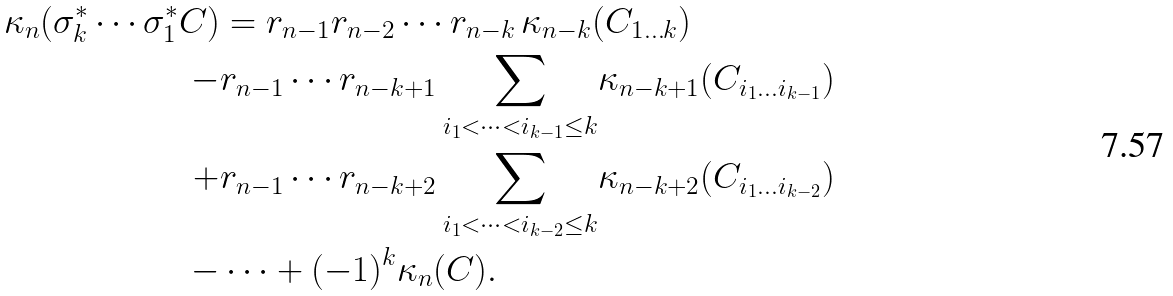<formula> <loc_0><loc_0><loc_500><loc_500>\kappa _ { n } ( \sigma _ { k } ^ { * } \cdots \sigma _ { 1 } ^ { * } C ) & = r _ { n - 1 } r _ { n - 2 } \cdots r _ { n - k } \, \kappa _ { n - k } ( C _ { 1 \dots k } ) \\ - & r _ { n - 1 } \cdots r _ { n - k + 1 } \, \underset { i _ { 1 } < \cdots < i _ { k - 1 } \leq k } { \sum } \kappa _ { n - k + 1 } ( C _ { i _ { 1 } \dots i _ { k - 1 } } ) \\ + & r _ { n - 1 } \cdots r _ { n - k + 2 } \, \underset { i _ { 1 } < \cdots < i _ { k - 2 } \leq k } { \sum } \kappa _ { n - k + 2 } ( C _ { i _ { 1 } \dots i _ { k - 2 } } ) \\ - & \dots + ( - 1 ) ^ { k } \kappa _ { n } ( C ) .</formula> 